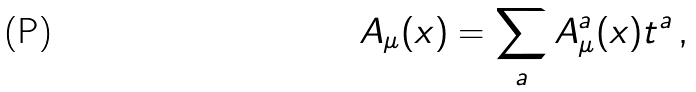<formula> <loc_0><loc_0><loc_500><loc_500>A _ { \mu } ( x ) = \sum _ { a } A _ { \mu } ^ { a } ( x ) t ^ { a } \, ,</formula> 